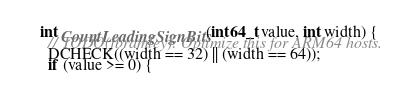<code> <loc_0><loc_0><loc_500><loc_500><_C++_>

int CountLeadingSignBits(int64_t value, int width) {
  // TODO(jbramley): Optimize this for ARM64 hosts.
  DCHECK((width == 32) || (width == 64));
  if (value >= 0) {</code> 